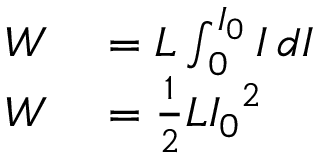<formula> <loc_0><loc_0><loc_500><loc_500>\begin{array} { r l } { W } & = L \int _ { 0 } ^ { I _ { 0 } } I \, d I } \\ { W } & = { \frac { 1 } { 2 } } L { I _ { 0 } } ^ { 2 } } \end{array}</formula> 